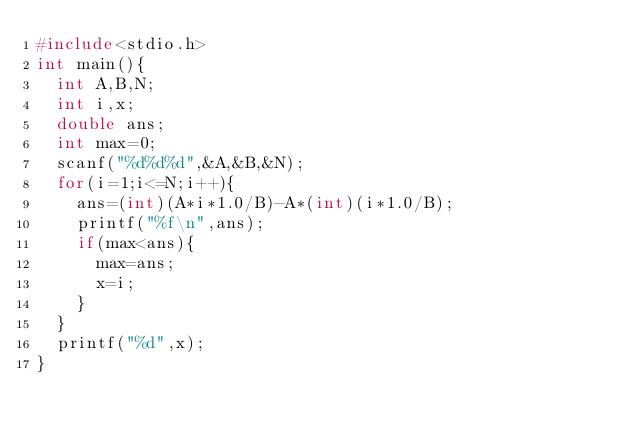Convert code to text. <code><loc_0><loc_0><loc_500><loc_500><_C_>#include<stdio.h>
int main(){
  int A,B,N;
  int i,x;
  double ans;
  int max=0;
  scanf("%d%d%d",&A,&B,&N);
  for(i=1;i<=N;i++){
    ans=(int)(A*i*1.0/B)-A*(int)(i*1.0/B);
    printf("%f\n",ans);
    if(max<ans){
      max=ans;
      x=i;
    }
  }
  printf("%d",x);
}</code> 